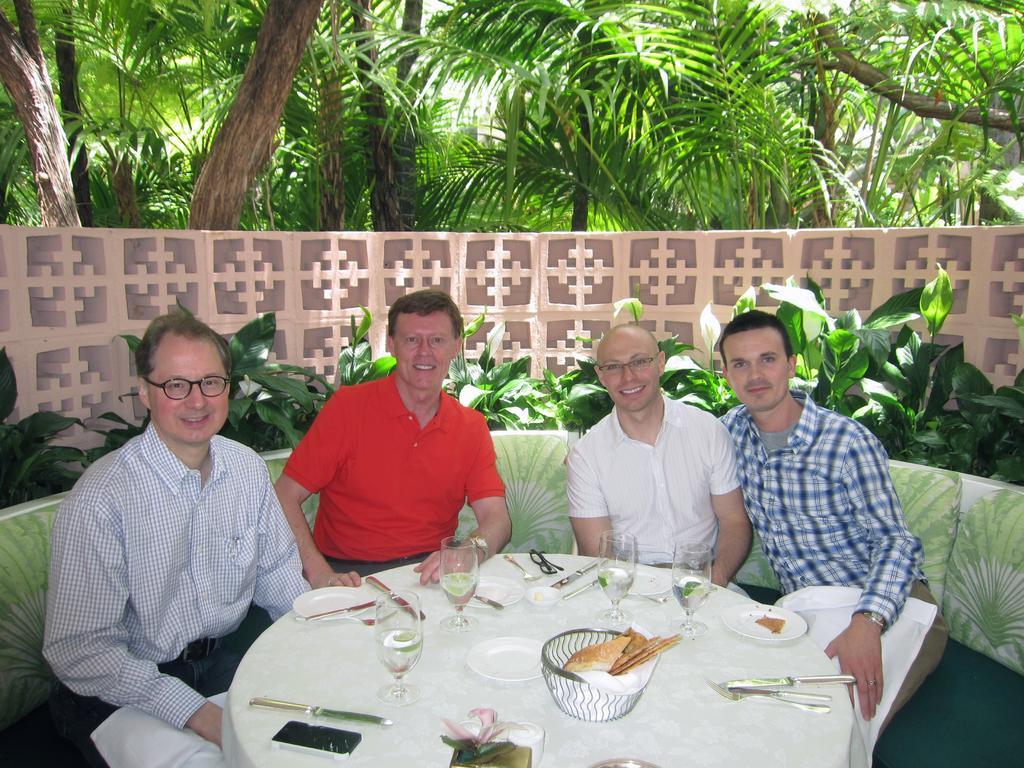How would you summarize this image in a sentence or two? In this image, we can see group of people are sat on the sofa. They are smiling. At the bottom, we can see white color table, few items are placed on it. At the background, there are so many plants and wall here, we can see trees. 